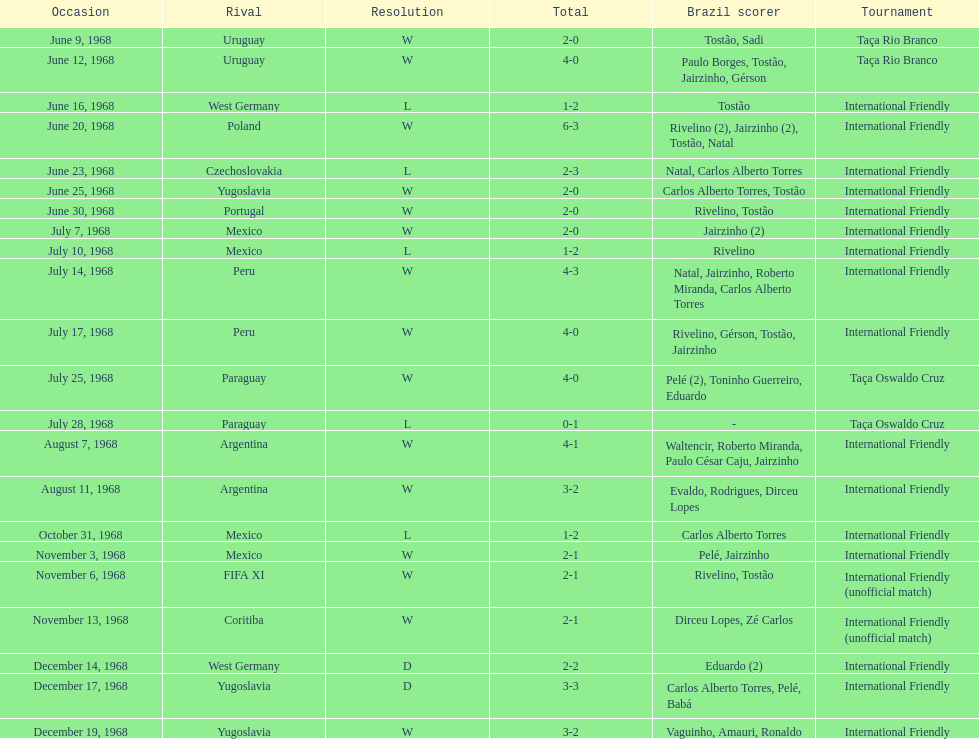What year has the highest scoring game? 1968. 